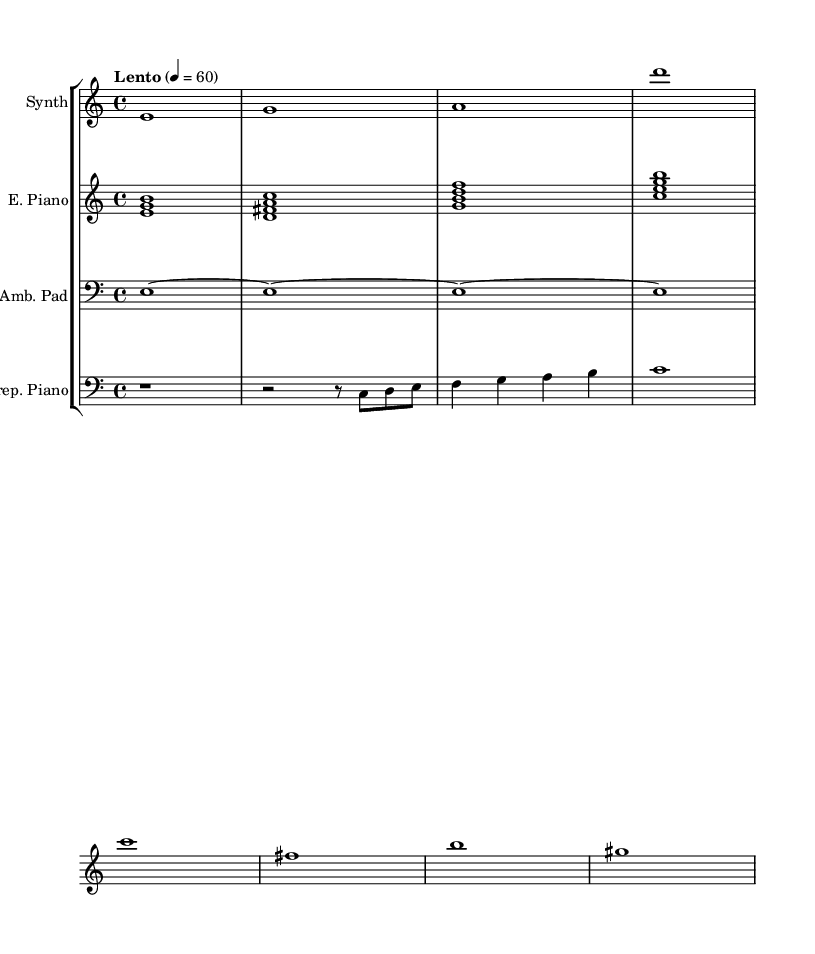What is the time signature of this music? The time signature indicated at the beginning of the music is 4/4, meaning there are four beats per measure.
Answer: 4/4 What tempo marking is present in the score? The score shows a tempo marking of "Lento" with a metronome marking of 60 beats per minute, indicating a slow and relaxed pace.
Answer: Lento What instruments are featured in the score? The score lists four instruments: Synth, Electric Piano, Ambient Pad, and Prepared Piano, each indicated in their respective staff.
Answer: Synth, Electric Piano, Ambient Pad, Prepared Piano How many measures are there in the synthesizer part? The synthesizer part has 8 measures, as indicated by the notation and spacing of the notes in the staff.
Answer: 8 What type of harmony is employed in the electric piano chords? The electric piano features triadic harmony, as each chord consists of three notes played together, indicating a clear structural approach to harmony.
Answer: Triadic Which instrument includes a rest at the beginning of its part? The prepared piano part starts with a rest (r1), indicating silence for the first measure before any notes are played.
Answer: Prepared Piano 